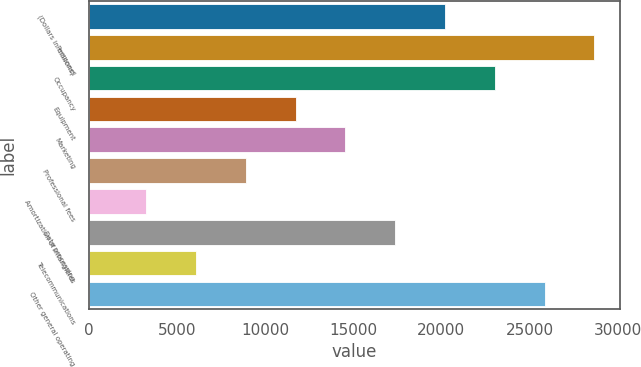Convert chart. <chart><loc_0><loc_0><loc_500><loc_500><bar_chart><fcel>(Dollars in millions)<fcel>Personnel<fcel>Occupancy<fcel>Equipment<fcel>Marketing<fcel>Professional fees<fcel>Amortization of intangibles<fcel>Data processing<fcel>Telecommunications<fcel>Other general operating<nl><fcel>20200.3<fcel>28681<fcel>23027.2<fcel>11719.6<fcel>14546.5<fcel>8892.7<fcel>3238.9<fcel>17373.4<fcel>6065.8<fcel>25854.1<nl></chart> 